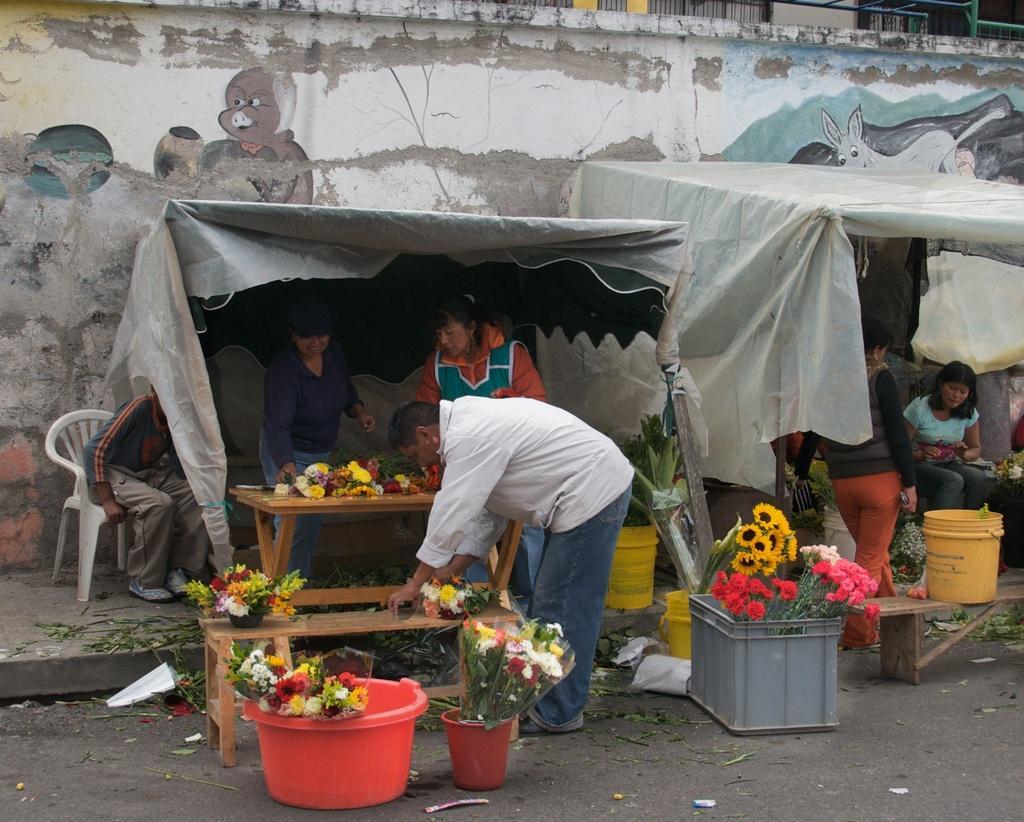Could you give a brief overview of what you see in this image? There are six people on the image preparing bouquets with different flowers on the road under the tent. There are flowers like rose, sunflower. There is a painting of a pig on the wall behind the tent. 